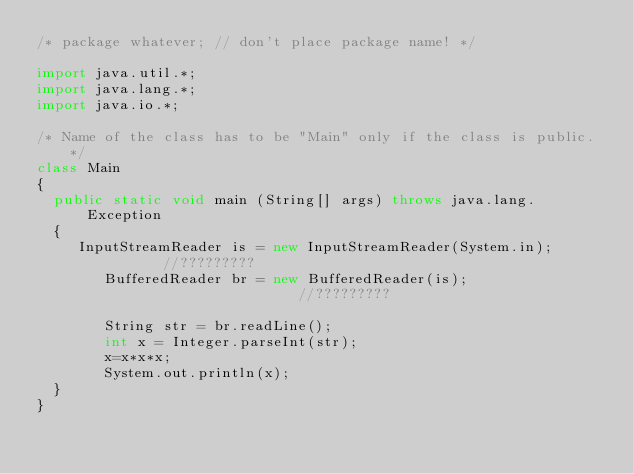<code> <loc_0><loc_0><loc_500><loc_500><_Java_>/* package whatever; // don't place package name! */

import java.util.*;
import java.lang.*;
import java.io.*;

/* Name of the class has to be "Main" only if the class is public. */
class Main
{
	public static void main (String[] args) throws java.lang.Exception
	{
		 InputStreamReader is = new InputStreamReader(System.in);       //?????????
        BufferedReader br = new BufferedReader(is);                    //?????????

        String str = br.readLine(); 
        int x = Integer.parseInt(str);
        x=x*x*x;
        System.out.println(x);
	}
}</code> 